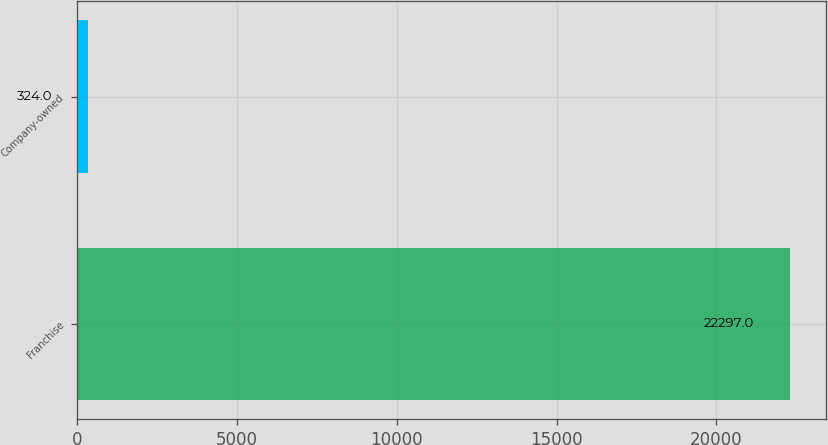<chart> <loc_0><loc_0><loc_500><loc_500><bar_chart><fcel>Franchise<fcel>Company-owned<nl><fcel>22297<fcel>324<nl></chart> 